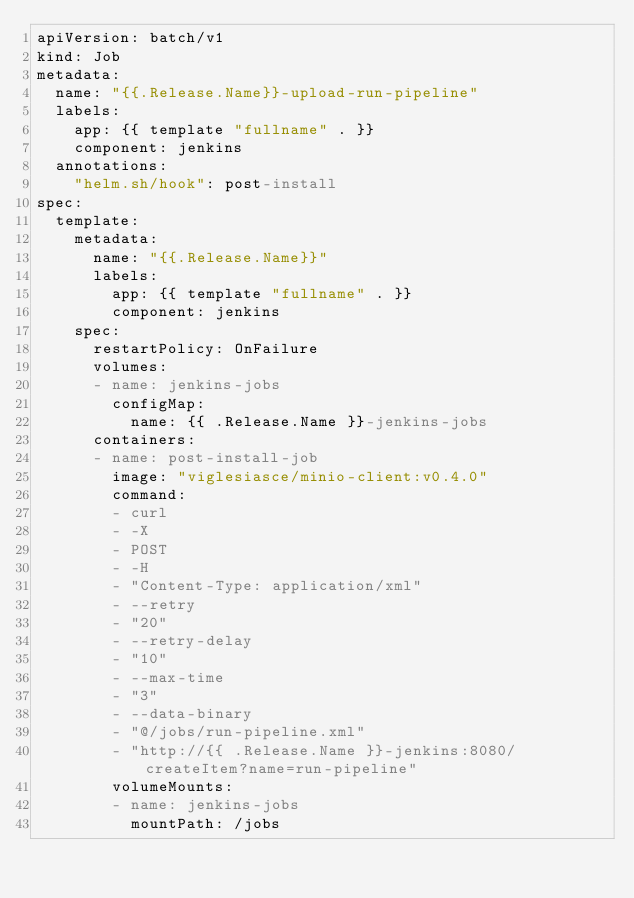Convert code to text. <code><loc_0><loc_0><loc_500><loc_500><_YAML_>apiVersion: batch/v1
kind: Job
metadata:
  name: "{{.Release.Name}}-upload-run-pipeline"
  labels:
    app: {{ template "fullname" . }}
    component: jenkins
  annotations:
    "helm.sh/hook": post-install
spec:
  template:
    metadata:
      name: "{{.Release.Name}}"
      labels:
        app: {{ template "fullname" . }}
        component: jenkins
    spec:
      restartPolicy: OnFailure
      volumes:
      - name: jenkins-jobs
        configMap:
          name: {{ .Release.Name }}-jenkins-jobs
      containers:
      - name: post-install-job
        image: "viglesiasce/minio-client:v0.4.0"
        command:
        - curl
        - -X
        - POST
        - -H
        - "Content-Type: application/xml"
        - --retry
        - "20"
        - --retry-delay
        - "10"
        - --max-time
        - "3"
        - --data-binary
        - "@/jobs/run-pipeline.xml"
        - "http://{{ .Release.Name }}-jenkins:8080/createItem?name=run-pipeline"
        volumeMounts:
        - name: jenkins-jobs
          mountPath: /jobs
</code> 